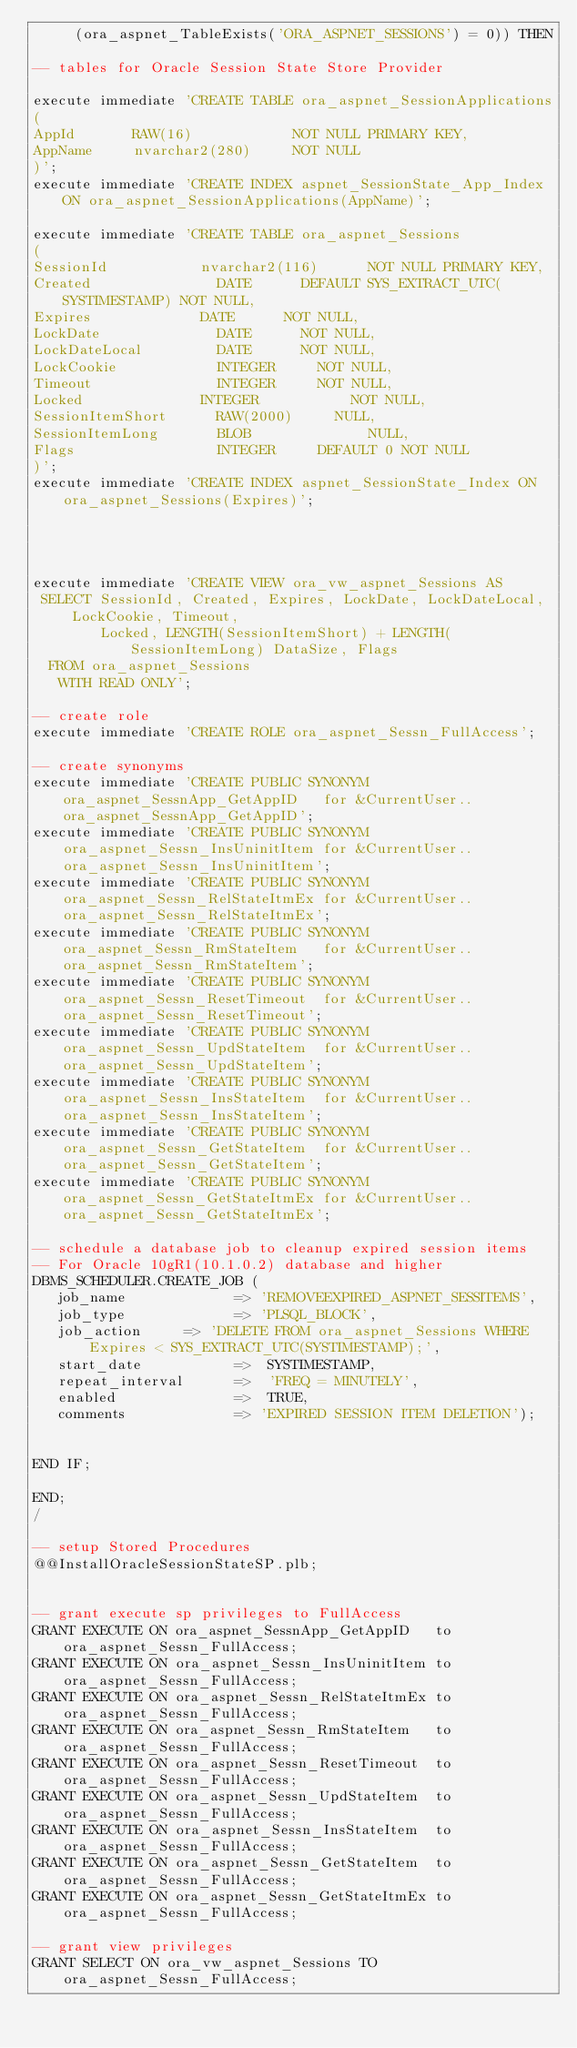Convert code to text. <code><loc_0><loc_0><loc_500><loc_500><_SQL_>     (ora_aspnet_TableExists('ORA_ASPNET_SESSIONS') = 0)) THEN

-- tables for Oracle Session State Store Provider

execute immediate 'CREATE TABLE ora_aspnet_SessionApplications
(
AppId     	RAW(16)            NOT NULL PRIMARY KEY,
AppName   	nvarchar2(280)     NOT NULL
)';
execute immediate 'CREATE INDEX aspnet_SessionState_App_Index ON ora_aspnet_SessionApplications(AppName)';

execute immediate 'CREATE TABLE ora_aspnet_Sessions
(
SessionId          	nvarchar2(116)    	NOT NULL PRIMARY KEY,
Created             	DATE 			DEFAULT SYS_EXTRACT_UTC(SYSTIMESTAMP) NOT NULL,
Expires            	DATE			NOT NULL,
LockDate            	DATE 			NOT NULL,
LockDateLocal       	DATE 			NOT NULL,
LockCookie          	INTEGER			NOT NULL,
Timeout             	INTEGER			NOT NULL,
Locked             	INTEGER        		NOT NULL,
SessionItemShort    	RAW(2000) 		NULL,
SessionItemLong     	BLOB           		NULL,
Flags               	INTEGER			DEFAULT 0 NOT NULL
)';
execute immediate 'CREATE INDEX aspnet_SessionState_Index ON ora_aspnet_Sessions(Expires)';




execute immediate 'CREATE VIEW ora_vw_aspnet_Sessions AS
 SELECT SessionId, Created, Expires, LockDate, LockDateLocal, LockCookie, Timeout, 
        Locked, LENGTH(SessionItemShort) + LENGTH(SessionItemLong) DataSize, Flags
  FROM ora_aspnet_Sessions
   WITH READ ONLY';

-- create role
execute immediate 'CREATE ROLE ora_aspnet_Sessn_FullAccess';

-- create synonyms
execute immediate 'CREATE PUBLIC SYNONYM ora_aspnet_SessnApp_GetAppID   for &CurrentUser..ora_aspnet_SessnApp_GetAppID';
execute immediate 'CREATE PUBLIC SYNONYM ora_aspnet_Sessn_InsUninitItem for &CurrentUser..ora_aspnet_Sessn_InsUninitItem';
execute immediate 'CREATE PUBLIC SYNONYM ora_aspnet_Sessn_RelStateItmEx for &CurrentUser..ora_aspnet_Sessn_RelStateItmEx';
execute immediate 'CREATE PUBLIC SYNONYM ora_aspnet_Sessn_RmStateItem   for &CurrentUser..ora_aspnet_Sessn_RmStateItem';
execute immediate 'CREATE PUBLIC SYNONYM ora_aspnet_Sessn_ResetTimeout  for &CurrentUser..ora_aspnet_Sessn_ResetTimeout';
execute immediate 'CREATE PUBLIC SYNONYM ora_aspnet_Sessn_UpdStateItem  for &CurrentUser..ora_aspnet_Sessn_UpdStateItem';
execute immediate 'CREATE PUBLIC SYNONYM ora_aspnet_Sessn_InsStateItem  for &CurrentUser..ora_aspnet_Sessn_InsStateItem';
execute immediate 'CREATE PUBLIC SYNONYM ora_aspnet_Sessn_GetStateItem  for &CurrentUser..ora_aspnet_Sessn_GetStateItem';
execute immediate 'CREATE PUBLIC SYNONYM ora_aspnet_Sessn_GetStateItmEx for &CurrentUser..ora_aspnet_Sessn_GetStateItmEx';

-- schedule a database job to cleanup expired session items
-- For Oracle 10gR1(10.1.0.2) database and higher
DBMS_SCHEDULER.CREATE_JOB (
   job_name             => 'REMOVEEXPIRED_ASPNET_SESSITEMS',
   job_type            	=> 'PLSQL_BLOCK',
   job_action  		=> 'DELETE FROM ora_aspnet_Sessions WHERE Expires < SYS_EXTRACT_UTC(SYSTIMESTAMP);',
   start_date           =>  SYSTIMESTAMP,
   repeat_interval      =>  'FREQ = MINUTELY',
   enabled              =>  TRUE,
   comments             => 'EXPIRED SESSION ITEM DELETION');


END IF;

END;
/

-- setup Stored Procedures
@@InstallOracleSessionStateSP.plb;


-- grant execute sp privileges to FullAccess
GRANT EXECUTE ON ora_aspnet_SessnApp_GetAppID   to ora_aspnet_Sessn_FullAccess;
GRANT EXECUTE ON ora_aspnet_Sessn_InsUninitItem to ora_aspnet_Sessn_FullAccess;
GRANT EXECUTE ON ora_aspnet_Sessn_RelStateItmEx to ora_aspnet_Sessn_FullAccess;
GRANT EXECUTE ON ora_aspnet_Sessn_RmStateItem   to ora_aspnet_Sessn_FullAccess;
GRANT EXECUTE ON ora_aspnet_Sessn_ResetTimeout  to ora_aspnet_Sessn_FullAccess;
GRANT EXECUTE ON ora_aspnet_Sessn_UpdStateItem  to ora_aspnet_Sessn_FullAccess;
GRANT EXECUTE ON ora_aspnet_Sessn_InsStateItem  to ora_aspnet_Sessn_FullAccess;
GRANT EXECUTE ON ora_aspnet_Sessn_GetStateItem  to ora_aspnet_Sessn_FullAccess;
GRANT EXECUTE ON ora_aspnet_Sessn_GetStateItmEx to ora_aspnet_Sessn_FullAccess;

-- grant view privileges
GRANT SELECT ON ora_vw_aspnet_Sessions TO ora_aspnet_Sessn_FullAccess;</code> 